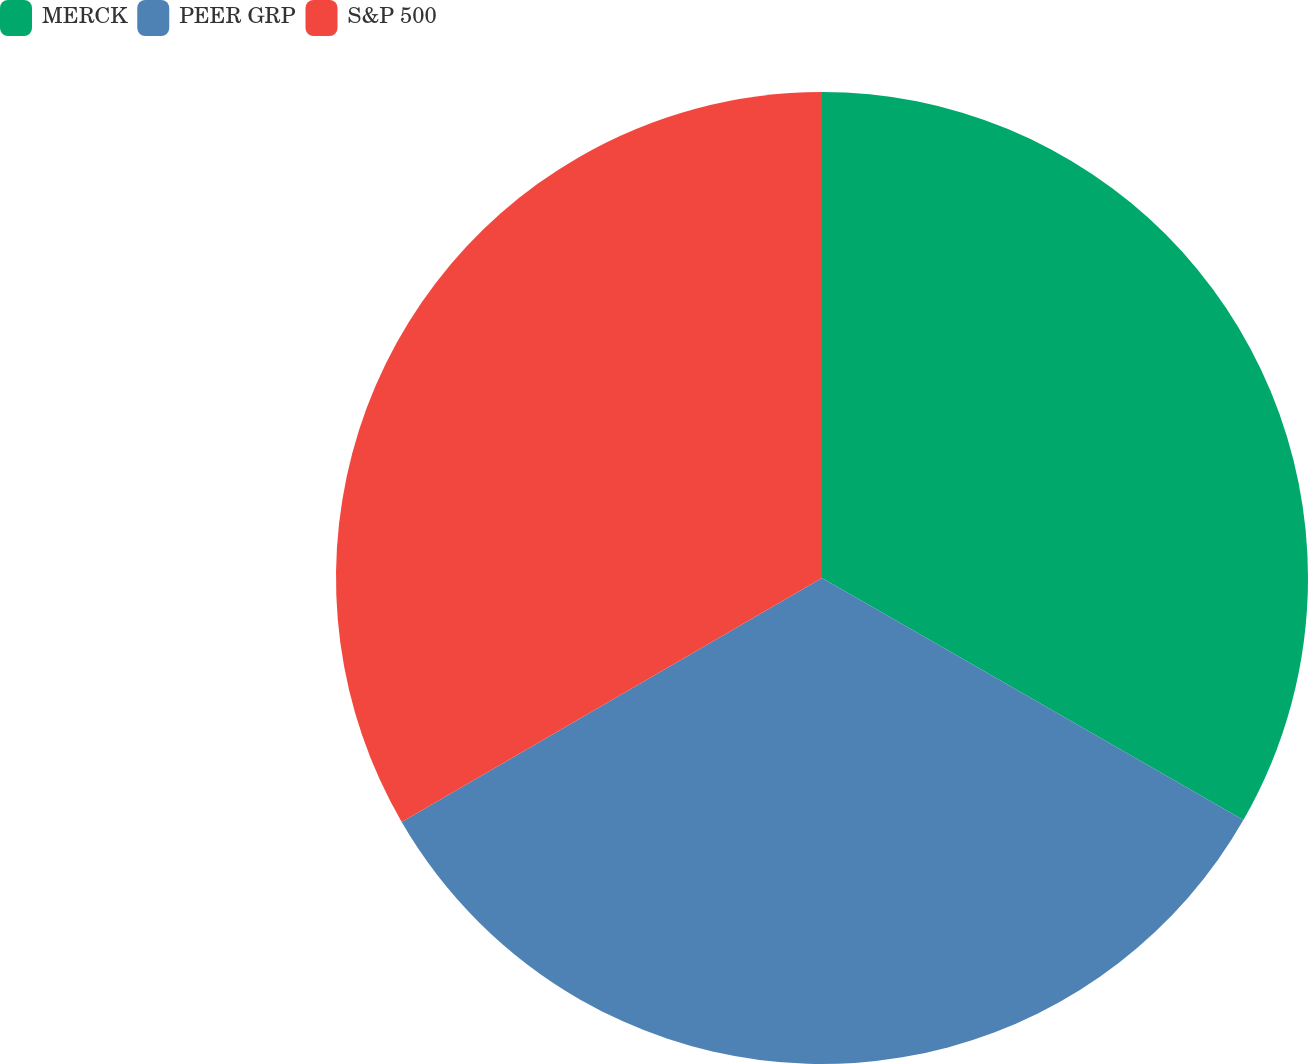Convert chart. <chart><loc_0><loc_0><loc_500><loc_500><pie_chart><fcel>MERCK<fcel>PEER GRP<fcel>S&P 500<nl><fcel>33.3%<fcel>33.33%<fcel>33.37%<nl></chart> 